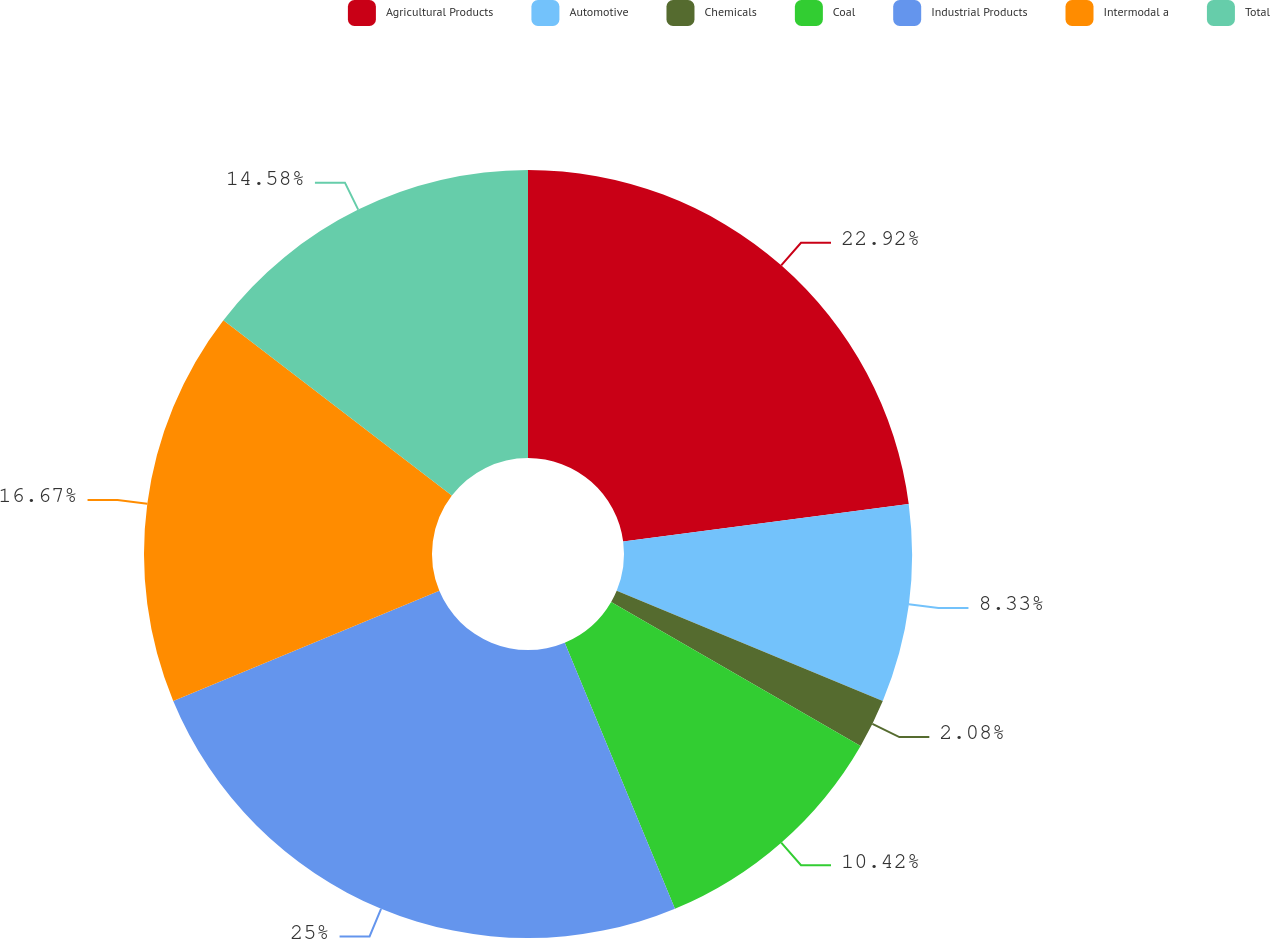Convert chart. <chart><loc_0><loc_0><loc_500><loc_500><pie_chart><fcel>Agricultural Products<fcel>Automotive<fcel>Chemicals<fcel>Coal<fcel>Industrial Products<fcel>Intermodal a<fcel>Total<nl><fcel>22.92%<fcel>8.33%<fcel>2.08%<fcel>10.42%<fcel>25.0%<fcel>16.67%<fcel>14.58%<nl></chart> 